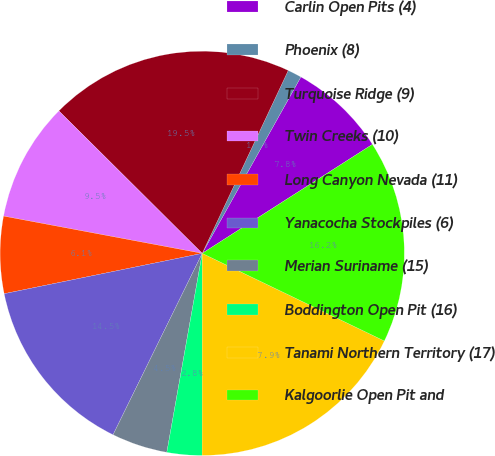Convert chart. <chart><loc_0><loc_0><loc_500><loc_500><pie_chart><fcel>Carlin Open Pits (4)<fcel>Phoenix (8)<fcel>Turquoise Ridge (9)<fcel>Twin Creeks (10)<fcel>Long Canyon Nevada (11)<fcel>Yanacocha Stockpiles (6)<fcel>Merian Suriname (15)<fcel>Boddington Open Pit (16)<fcel>Tanami Northern Territory (17)<fcel>Kalgoorlie Open Pit and<nl><fcel>7.82%<fcel>1.12%<fcel>19.55%<fcel>9.5%<fcel>6.15%<fcel>14.53%<fcel>4.47%<fcel>2.79%<fcel>17.88%<fcel>16.2%<nl></chart> 